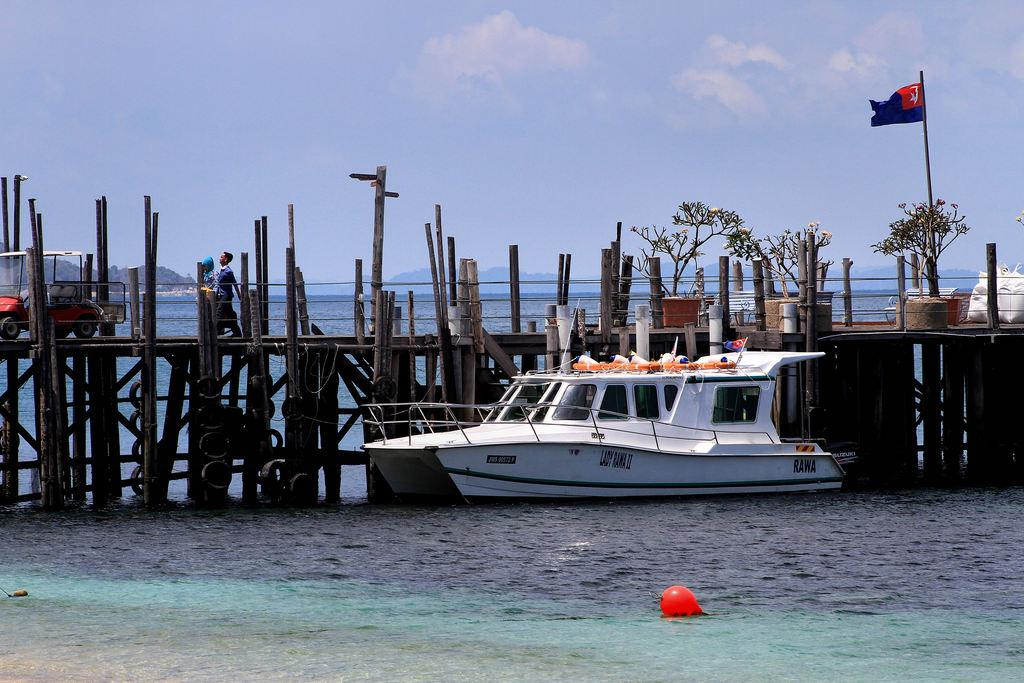What is the primary element in the image? There is water in the image. What is floating on the water? There is a boat in the image. What is attached to the boat? There is a flag in the image. What type of vegetation can be seen in the image? There are plants in the image. What structure is visible in the image? There is a bridge in the image. What is the person in the image doing? There is a person walking in the image. What type of transportation is present in the image? There is a vehicle in the image. What is visible in the sky in the image? The sky is visible in the image, and there are clouds in the sky. What type of popcorn is being served on the bridge in the image? There is no popcorn present in the image, and it does not show any food being served. Can you describe the person's elbow in the image? There is no specific focus on the person's elbow in the image, and it is not mentioned in the provided facts. 